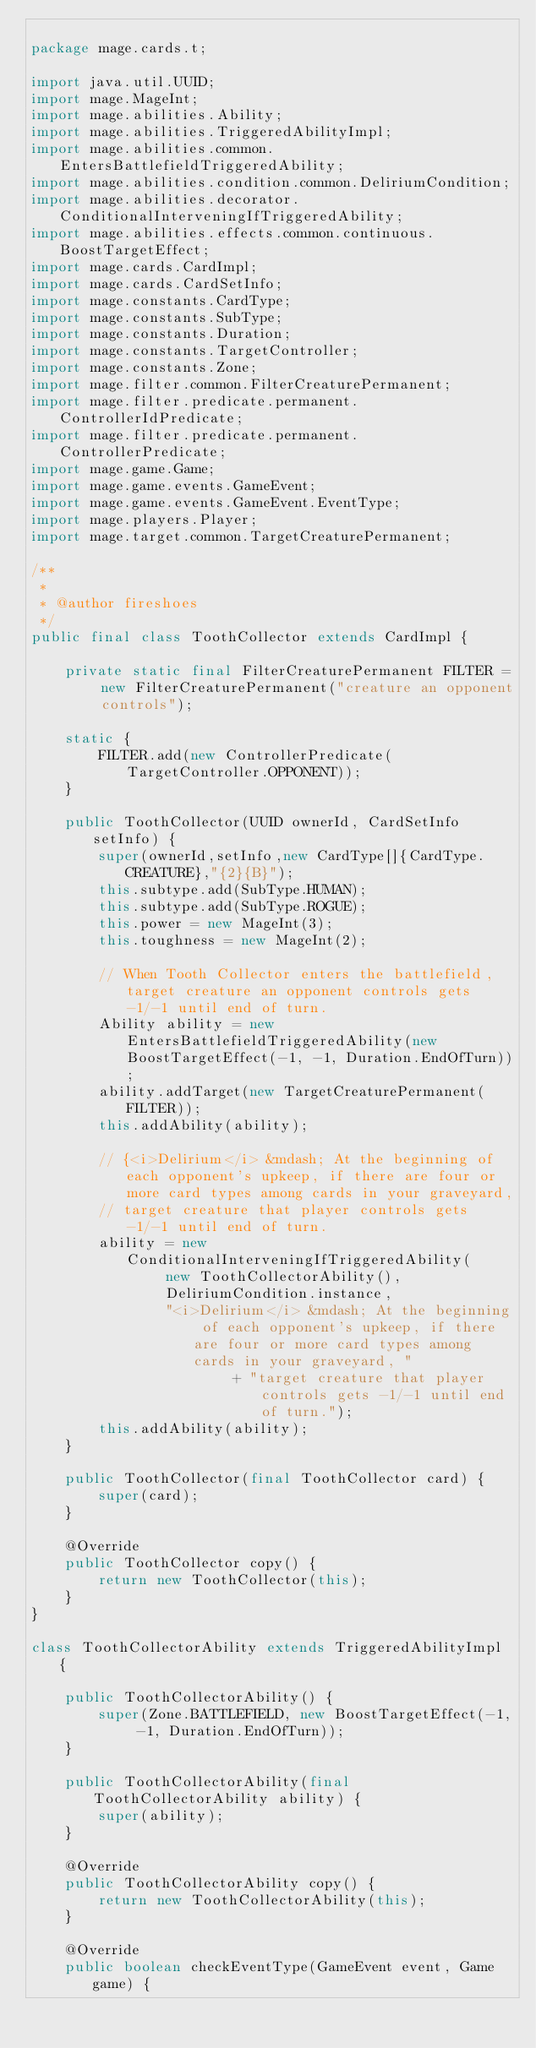<code> <loc_0><loc_0><loc_500><loc_500><_Java_>
package mage.cards.t;

import java.util.UUID;
import mage.MageInt;
import mage.abilities.Ability;
import mage.abilities.TriggeredAbilityImpl;
import mage.abilities.common.EntersBattlefieldTriggeredAbility;
import mage.abilities.condition.common.DeliriumCondition;
import mage.abilities.decorator.ConditionalInterveningIfTriggeredAbility;
import mage.abilities.effects.common.continuous.BoostTargetEffect;
import mage.cards.CardImpl;
import mage.cards.CardSetInfo;
import mage.constants.CardType;
import mage.constants.SubType;
import mage.constants.Duration;
import mage.constants.TargetController;
import mage.constants.Zone;
import mage.filter.common.FilterCreaturePermanent;
import mage.filter.predicate.permanent.ControllerIdPredicate;
import mage.filter.predicate.permanent.ControllerPredicate;
import mage.game.Game;
import mage.game.events.GameEvent;
import mage.game.events.GameEvent.EventType;
import mage.players.Player;
import mage.target.common.TargetCreaturePermanent;

/**
 *
 * @author fireshoes
 */
public final class ToothCollector extends CardImpl {

    private static final FilterCreaturePermanent FILTER = new FilterCreaturePermanent("creature an opponent controls");

    static {
        FILTER.add(new ControllerPredicate(TargetController.OPPONENT));
    }

    public ToothCollector(UUID ownerId, CardSetInfo setInfo) {
        super(ownerId,setInfo,new CardType[]{CardType.CREATURE},"{2}{B}");
        this.subtype.add(SubType.HUMAN);
        this.subtype.add(SubType.ROGUE);
        this.power = new MageInt(3);
        this.toughness = new MageInt(2);

        // When Tooth Collector enters the battlefield, target creature an opponent controls gets -1/-1 until end of turn.
        Ability ability = new EntersBattlefieldTriggeredAbility(new BoostTargetEffect(-1, -1, Duration.EndOfTurn));
        ability.addTarget(new TargetCreaturePermanent(FILTER));
        this.addAbility(ability);

        // {<i>Delirium</i> &mdash; At the beginning of each opponent's upkeep, if there are four or more card types among cards in your graveyard,
        // target creature that player controls gets -1/-1 until end of turn.
        ability = new ConditionalInterveningIfTriggeredAbility(
                new ToothCollectorAbility(),
                DeliriumCondition.instance,
                "<i>Delirium</i> &mdash; At the beginning of each opponent's upkeep, if there are four or more card types among cards in your graveyard, "
                        + "target creature that player controls gets -1/-1 until end of turn.");
        this.addAbility(ability);
    }

    public ToothCollector(final ToothCollector card) {
        super(card);
    }

    @Override
    public ToothCollector copy() {
        return new ToothCollector(this);
    }
}

class ToothCollectorAbility extends TriggeredAbilityImpl {

    public ToothCollectorAbility() {
        super(Zone.BATTLEFIELD, new BoostTargetEffect(-1, -1, Duration.EndOfTurn));
    }

    public ToothCollectorAbility(final ToothCollectorAbility ability) {
        super(ability);
    }

    @Override
    public ToothCollectorAbility copy() {
        return new ToothCollectorAbility(this);
    }

    @Override
    public boolean checkEventType(GameEvent event, Game game) {</code> 